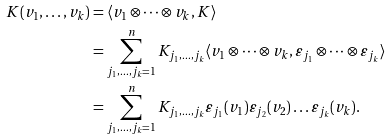<formula> <loc_0><loc_0><loc_500><loc_500>K ( v _ { 1 } , \dots , v _ { k } ) & = \langle v _ { 1 } \otimes \dots \otimes v _ { k } , K \rangle \\ & = \sum _ { j _ { 1 } , \dots , j _ { k } = 1 } ^ { n } K _ { j _ { 1 } , \dots , j _ { k } } \langle v _ { 1 } \otimes \dots \otimes v _ { k } , \varepsilon _ { j _ { 1 } } \otimes \dots \otimes \varepsilon _ { j _ { k } } \rangle \\ & = \sum _ { j _ { 1 } , \dots , j _ { k } = 1 } ^ { n } K _ { j _ { 1 } , \dots , j _ { k } } \varepsilon _ { j _ { 1 } } ( v _ { 1 } ) \varepsilon _ { j _ { 2 } } ( v _ { 2 } ) \dots \varepsilon _ { j _ { k } } ( v _ { k } ) .</formula> 